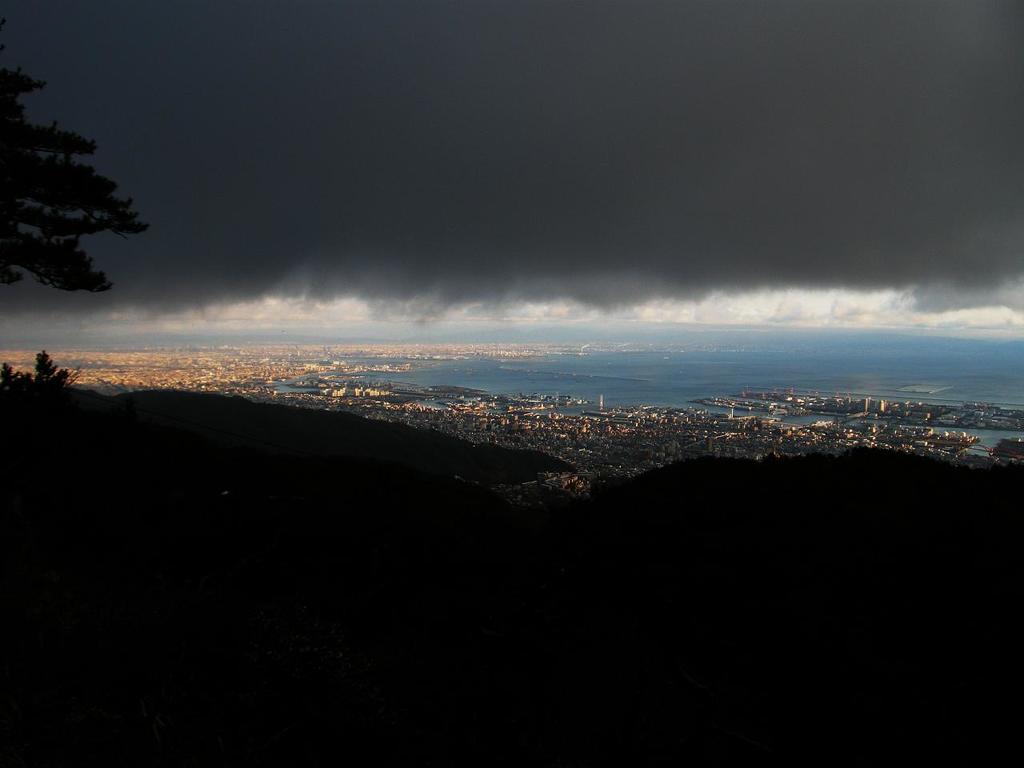How would you summarize this image in a sentence or two? In the center of the image we can see the sky, clouds, water, buildings, poles, trees and a few other objects. 